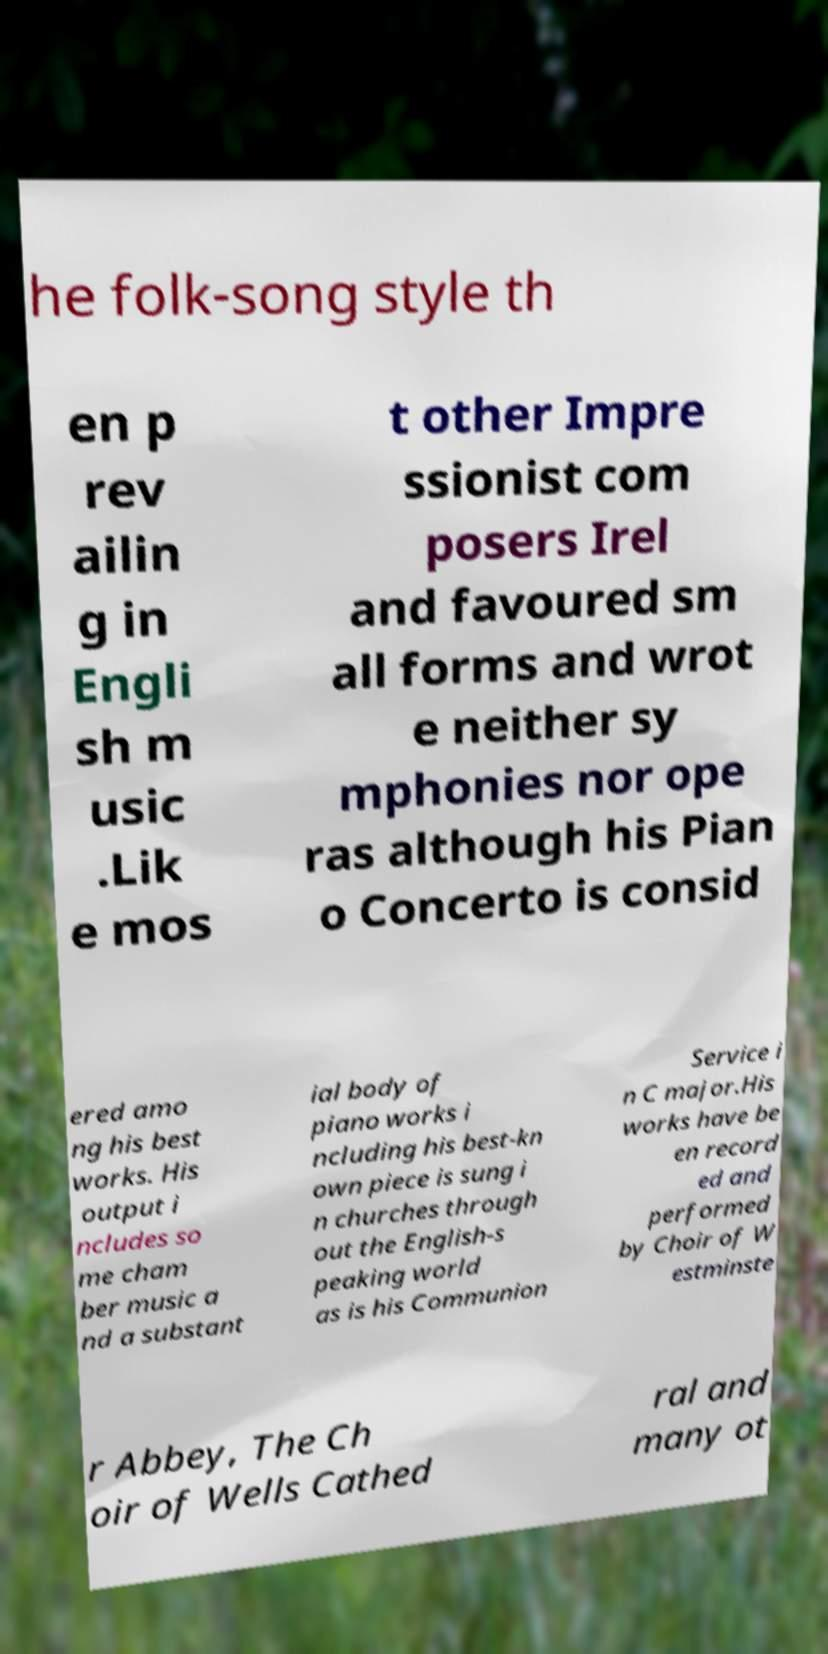Could you assist in decoding the text presented in this image and type it out clearly? he folk-song style th en p rev ailin g in Engli sh m usic .Lik e mos t other Impre ssionist com posers Irel and favoured sm all forms and wrot e neither sy mphonies nor ope ras although his Pian o Concerto is consid ered amo ng his best works. His output i ncludes so me cham ber music a nd a substant ial body of piano works i ncluding his best-kn own piece is sung i n churches through out the English-s peaking world as is his Communion Service i n C major.His works have be en record ed and performed by Choir of W estminste r Abbey, The Ch oir of Wells Cathed ral and many ot 